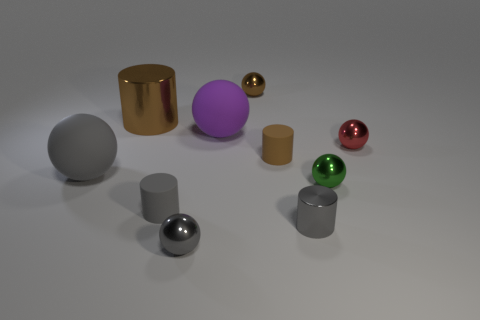Is the color of the big sphere in front of the red ball the same as the small ball on the left side of the brown sphere?
Keep it short and to the point. Yes. Are the large ball behind the big gray rubber object and the green thing made of the same material?
Keep it short and to the point. No. There is a rubber object that is in front of the brown matte object and right of the large gray matte object; what shape is it?
Your answer should be very brief. Cylinder. What number of objects are either large matte objects that are on the left side of the large brown cylinder or tiny gray matte cylinders?
Offer a terse response. 2. There is a sphere that is the same color as the large cylinder; what is it made of?
Your answer should be very brief. Metal. There is a matte ball that is in front of the purple object on the left side of the tiny green object; are there any spheres that are to the left of it?
Your response must be concise. No. Is the number of gray objects that are on the right side of the gray metal cylinder less than the number of green objects that are to the left of the big gray ball?
Provide a succinct answer. No. There is a large object that is made of the same material as the green ball; what is its color?
Offer a terse response. Brown. What color is the small sphere that is in front of the metal cylinder that is in front of the gray rubber cylinder?
Keep it short and to the point. Gray. Is there a small rubber sphere that has the same color as the large metallic cylinder?
Ensure brevity in your answer.  No. 